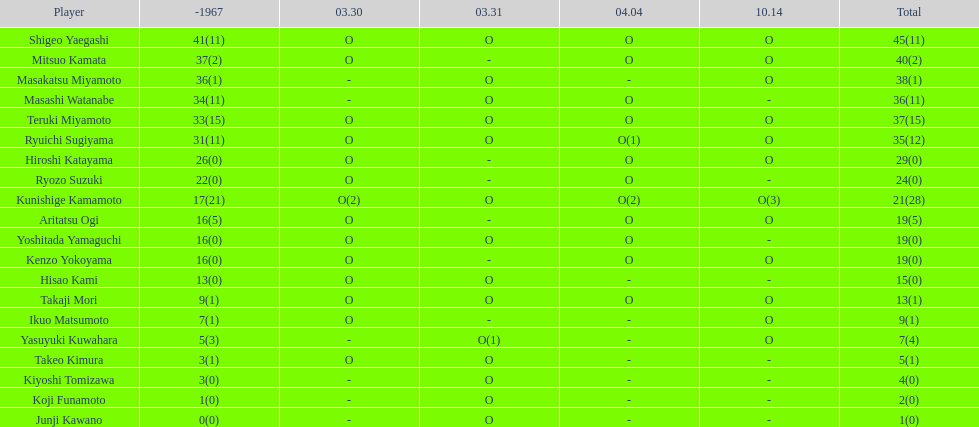Did mitsuo kamata accumulate over 40 overall points? No. 